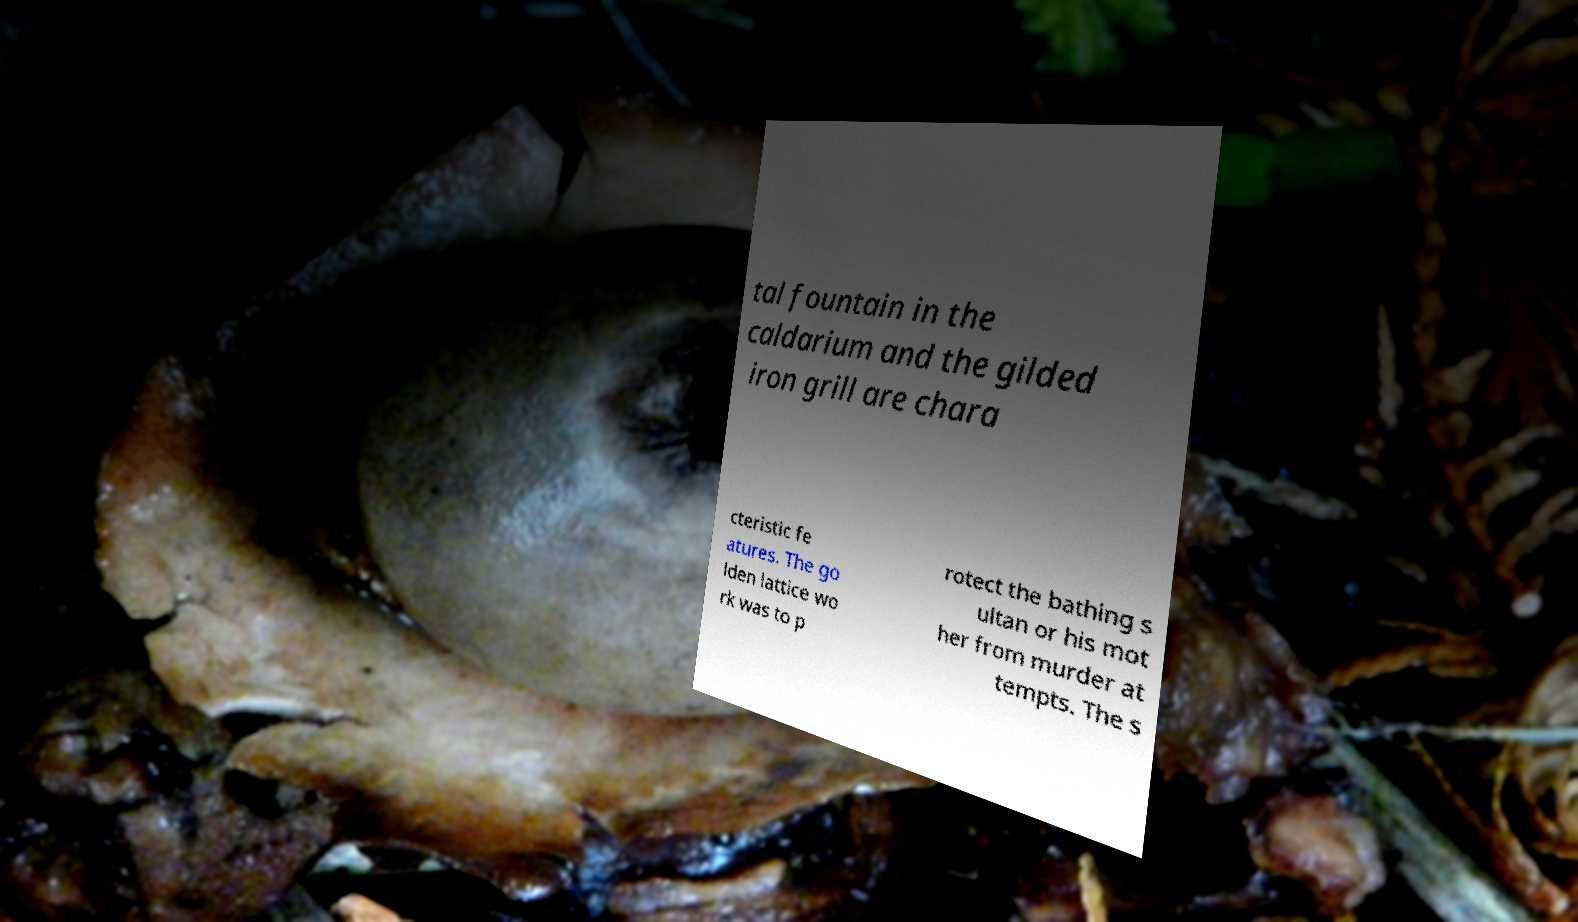Please read and relay the text visible in this image. What does it say? tal fountain in the caldarium and the gilded iron grill are chara cteristic fe atures. The go lden lattice wo rk was to p rotect the bathing s ultan or his mot her from murder at tempts. The s 